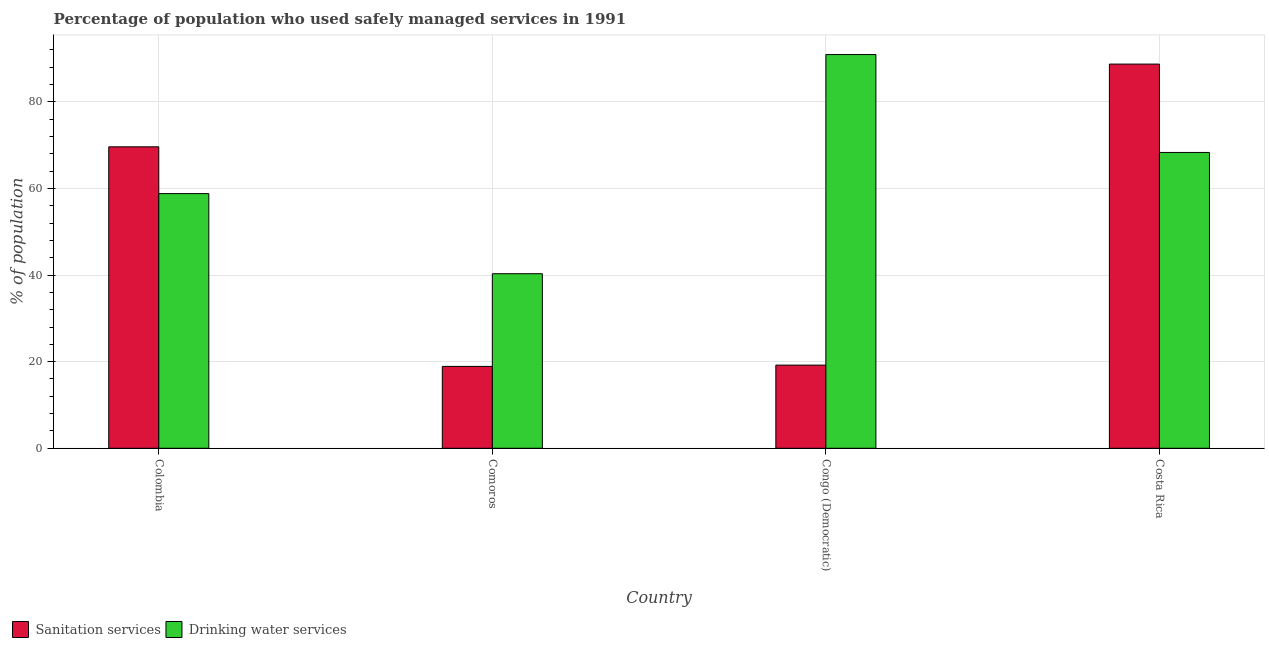How many different coloured bars are there?
Your answer should be compact. 2. Are the number of bars per tick equal to the number of legend labels?
Offer a terse response. Yes. Are the number of bars on each tick of the X-axis equal?
Keep it short and to the point. Yes. How many bars are there on the 4th tick from the left?
Ensure brevity in your answer.  2. How many bars are there on the 1st tick from the right?
Provide a succinct answer. 2. What is the percentage of population who used sanitation services in Colombia?
Offer a terse response. 69.6. Across all countries, what is the maximum percentage of population who used sanitation services?
Provide a short and direct response. 88.7. Across all countries, what is the minimum percentage of population who used drinking water services?
Offer a very short reply. 40.3. In which country was the percentage of population who used sanitation services maximum?
Your response must be concise. Costa Rica. In which country was the percentage of population who used drinking water services minimum?
Your answer should be compact. Comoros. What is the total percentage of population who used sanitation services in the graph?
Your answer should be very brief. 196.4. What is the difference between the percentage of population who used drinking water services in Comoros and that in Costa Rica?
Make the answer very short. -28. What is the difference between the percentage of population who used drinking water services in Costa Rica and the percentage of population who used sanitation services in Colombia?
Provide a succinct answer. -1.3. What is the average percentage of population who used sanitation services per country?
Your answer should be compact. 49.1. What is the difference between the percentage of population who used drinking water services and percentage of population who used sanitation services in Costa Rica?
Ensure brevity in your answer.  -20.4. What is the ratio of the percentage of population who used drinking water services in Congo (Democratic) to that in Costa Rica?
Ensure brevity in your answer.  1.33. Is the percentage of population who used sanitation services in Colombia less than that in Congo (Democratic)?
Give a very brief answer. No. What is the difference between the highest and the second highest percentage of population who used sanitation services?
Offer a very short reply. 19.1. What is the difference between the highest and the lowest percentage of population who used drinking water services?
Provide a short and direct response. 50.6. In how many countries, is the percentage of population who used sanitation services greater than the average percentage of population who used sanitation services taken over all countries?
Your answer should be very brief. 2. What does the 2nd bar from the left in Costa Rica represents?
Ensure brevity in your answer.  Drinking water services. What does the 2nd bar from the right in Congo (Democratic) represents?
Your response must be concise. Sanitation services. How many countries are there in the graph?
Your answer should be very brief. 4. What is the difference between two consecutive major ticks on the Y-axis?
Provide a short and direct response. 20. Are the values on the major ticks of Y-axis written in scientific E-notation?
Provide a succinct answer. No. Does the graph contain any zero values?
Offer a very short reply. No. Where does the legend appear in the graph?
Offer a very short reply. Bottom left. What is the title of the graph?
Your answer should be very brief. Percentage of population who used safely managed services in 1991. Does "Lower secondary education" appear as one of the legend labels in the graph?
Give a very brief answer. No. What is the label or title of the X-axis?
Your response must be concise. Country. What is the label or title of the Y-axis?
Offer a very short reply. % of population. What is the % of population in Sanitation services in Colombia?
Your answer should be compact. 69.6. What is the % of population in Drinking water services in Colombia?
Your response must be concise. 58.8. What is the % of population in Sanitation services in Comoros?
Your answer should be compact. 18.9. What is the % of population in Drinking water services in Comoros?
Your answer should be compact. 40.3. What is the % of population in Sanitation services in Congo (Democratic)?
Give a very brief answer. 19.2. What is the % of population in Drinking water services in Congo (Democratic)?
Provide a succinct answer. 90.9. What is the % of population of Sanitation services in Costa Rica?
Provide a succinct answer. 88.7. What is the % of population in Drinking water services in Costa Rica?
Make the answer very short. 68.3. Across all countries, what is the maximum % of population of Sanitation services?
Provide a succinct answer. 88.7. Across all countries, what is the maximum % of population in Drinking water services?
Your answer should be compact. 90.9. Across all countries, what is the minimum % of population of Sanitation services?
Offer a terse response. 18.9. Across all countries, what is the minimum % of population in Drinking water services?
Offer a terse response. 40.3. What is the total % of population in Sanitation services in the graph?
Provide a short and direct response. 196.4. What is the total % of population of Drinking water services in the graph?
Ensure brevity in your answer.  258.3. What is the difference between the % of population of Sanitation services in Colombia and that in Comoros?
Keep it short and to the point. 50.7. What is the difference between the % of population of Drinking water services in Colombia and that in Comoros?
Make the answer very short. 18.5. What is the difference between the % of population in Sanitation services in Colombia and that in Congo (Democratic)?
Your answer should be compact. 50.4. What is the difference between the % of population of Drinking water services in Colombia and that in Congo (Democratic)?
Your answer should be very brief. -32.1. What is the difference between the % of population of Sanitation services in Colombia and that in Costa Rica?
Your response must be concise. -19.1. What is the difference between the % of population in Drinking water services in Colombia and that in Costa Rica?
Give a very brief answer. -9.5. What is the difference between the % of population of Drinking water services in Comoros and that in Congo (Democratic)?
Offer a very short reply. -50.6. What is the difference between the % of population of Sanitation services in Comoros and that in Costa Rica?
Keep it short and to the point. -69.8. What is the difference between the % of population in Sanitation services in Congo (Democratic) and that in Costa Rica?
Make the answer very short. -69.5. What is the difference between the % of population of Drinking water services in Congo (Democratic) and that in Costa Rica?
Make the answer very short. 22.6. What is the difference between the % of population in Sanitation services in Colombia and the % of population in Drinking water services in Comoros?
Make the answer very short. 29.3. What is the difference between the % of population in Sanitation services in Colombia and the % of population in Drinking water services in Congo (Democratic)?
Provide a short and direct response. -21.3. What is the difference between the % of population of Sanitation services in Colombia and the % of population of Drinking water services in Costa Rica?
Ensure brevity in your answer.  1.3. What is the difference between the % of population in Sanitation services in Comoros and the % of population in Drinking water services in Congo (Democratic)?
Provide a succinct answer. -72. What is the difference between the % of population of Sanitation services in Comoros and the % of population of Drinking water services in Costa Rica?
Offer a very short reply. -49.4. What is the difference between the % of population of Sanitation services in Congo (Democratic) and the % of population of Drinking water services in Costa Rica?
Your answer should be compact. -49.1. What is the average % of population of Sanitation services per country?
Offer a very short reply. 49.1. What is the average % of population of Drinking water services per country?
Keep it short and to the point. 64.58. What is the difference between the % of population of Sanitation services and % of population of Drinking water services in Colombia?
Your response must be concise. 10.8. What is the difference between the % of population in Sanitation services and % of population in Drinking water services in Comoros?
Your response must be concise. -21.4. What is the difference between the % of population in Sanitation services and % of population in Drinking water services in Congo (Democratic)?
Your response must be concise. -71.7. What is the difference between the % of population of Sanitation services and % of population of Drinking water services in Costa Rica?
Your answer should be compact. 20.4. What is the ratio of the % of population in Sanitation services in Colombia to that in Comoros?
Your answer should be compact. 3.68. What is the ratio of the % of population of Drinking water services in Colombia to that in Comoros?
Give a very brief answer. 1.46. What is the ratio of the % of population in Sanitation services in Colombia to that in Congo (Democratic)?
Your response must be concise. 3.62. What is the ratio of the % of population in Drinking water services in Colombia to that in Congo (Democratic)?
Your answer should be compact. 0.65. What is the ratio of the % of population in Sanitation services in Colombia to that in Costa Rica?
Ensure brevity in your answer.  0.78. What is the ratio of the % of population in Drinking water services in Colombia to that in Costa Rica?
Your answer should be very brief. 0.86. What is the ratio of the % of population in Sanitation services in Comoros to that in Congo (Democratic)?
Make the answer very short. 0.98. What is the ratio of the % of population of Drinking water services in Comoros to that in Congo (Democratic)?
Keep it short and to the point. 0.44. What is the ratio of the % of population of Sanitation services in Comoros to that in Costa Rica?
Provide a succinct answer. 0.21. What is the ratio of the % of population of Drinking water services in Comoros to that in Costa Rica?
Make the answer very short. 0.59. What is the ratio of the % of population of Sanitation services in Congo (Democratic) to that in Costa Rica?
Give a very brief answer. 0.22. What is the ratio of the % of population of Drinking water services in Congo (Democratic) to that in Costa Rica?
Make the answer very short. 1.33. What is the difference between the highest and the second highest % of population of Drinking water services?
Keep it short and to the point. 22.6. What is the difference between the highest and the lowest % of population in Sanitation services?
Ensure brevity in your answer.  69.8. What is the difference between the highest and the lowest % of population in Drinking water services?
Give a very brief answer. 50.6. 